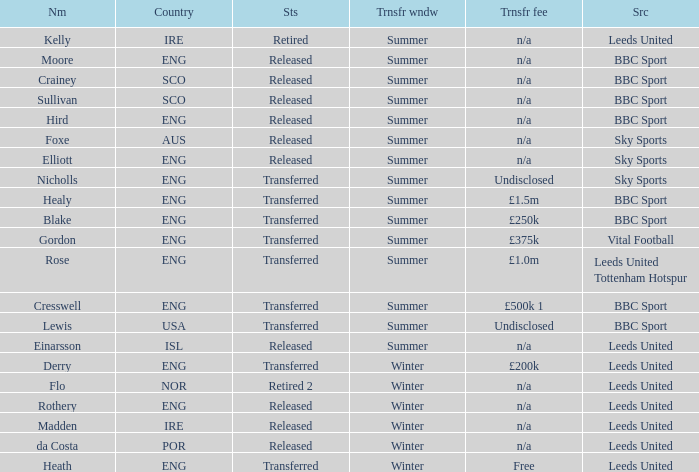What was the source of an ENG transfer that paid a £1.5m transfer fee? BBC Sport. 